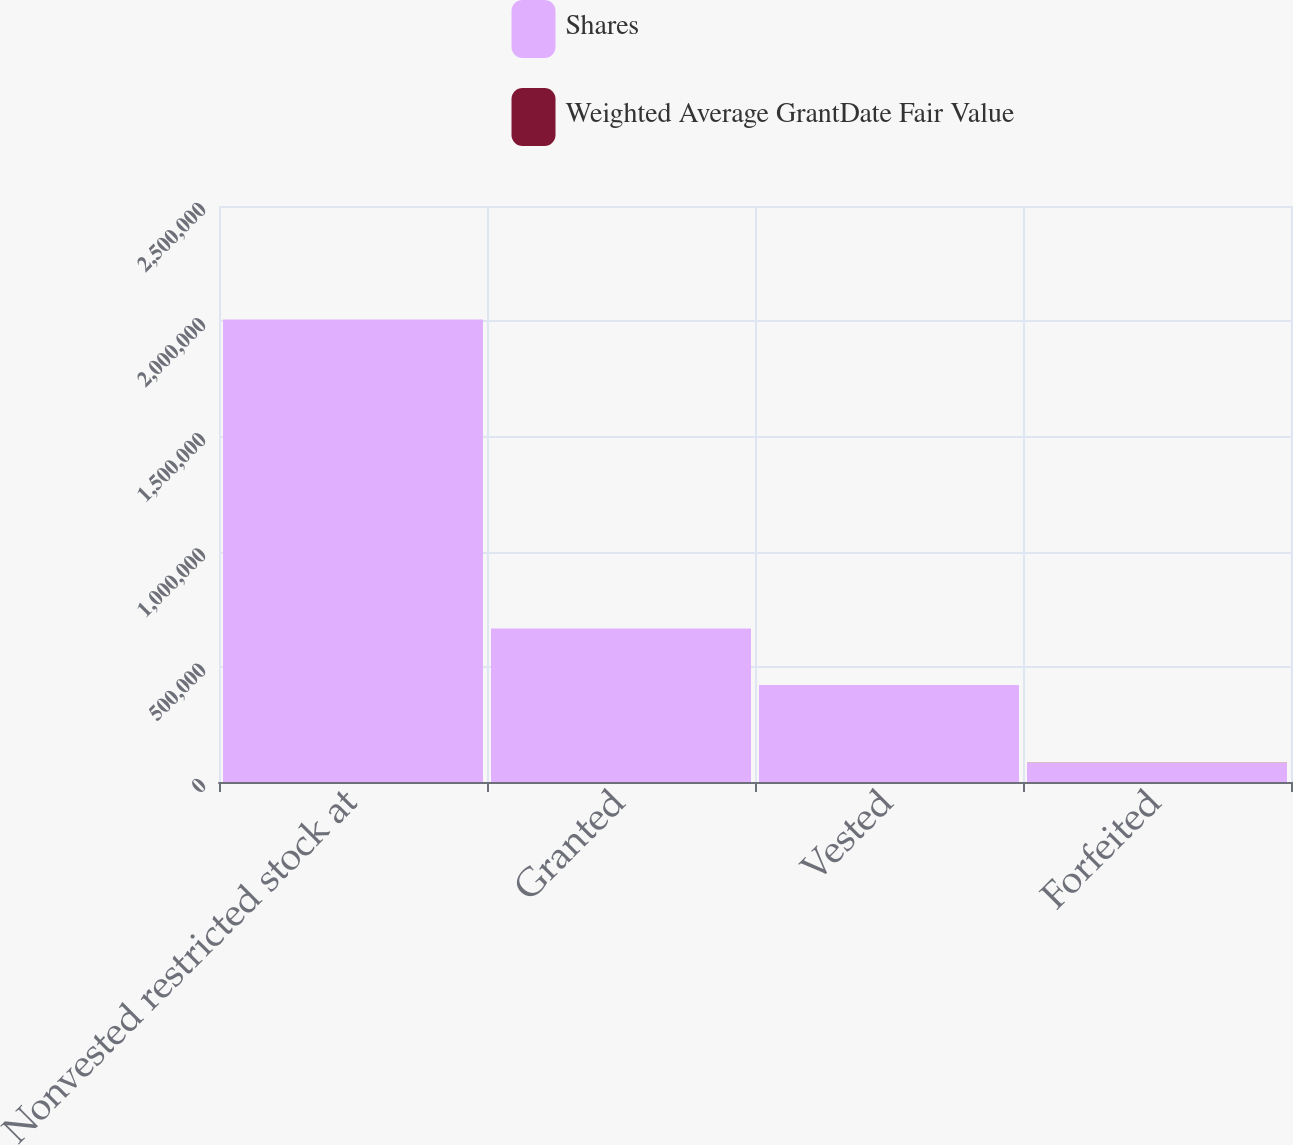<chart> <loc_0><loc_0><loc_500><loc_500><stacked_bar_chart><ecel><fcel>Nonvested restricted stock at<fcel>Granted<fcel>Vested<fcel>Forfeited<nl><fcel>Shares<fcel>2.0073e+06<fcel>666571<fcel>421261<fcel>82987<nl><fcel>Weighted Average GrantDate Fair Value<fcel>62.12<fcel>68.1<fcel>34.1<fcel>63.22<nl></chart> 